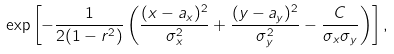<formula> <loc_0><loc_0><loc_500><loc_500>\exp \left [ - \frac { 1 } { 2 ( 1 - r ^ { 2 } ) } \left ( \frac { ( x - a _ { x } ) ^ { 2 } } { \sigma _ { x } ^ { 2 } } + \frac { ( y - a _ { y } ) ^ { 2 } } { \sigma _ { y } ^ { 2 } } - \frac { C } { \sigma _ { x } \sigma _ { y } } \right ) \right ] , \,</formula> 